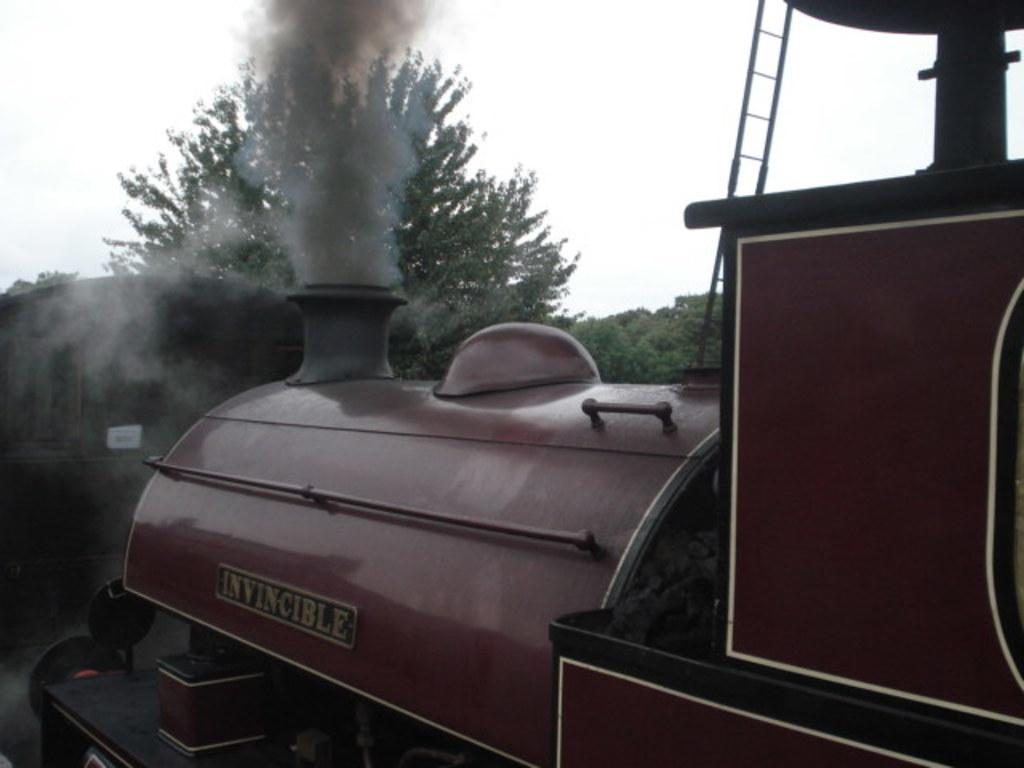What type of vehicle is in the image? There is a steam engine in the image. What object can be seen near the steam engine? There is a ladder in the image. What type of natural vegetation is visible in the image? There are trees in the image. What is visible above the steam engine and trees? The sky is visible in the image. What type of hammer is being used to create the effect seen in the image? There is no hammer or any effect being created in the image; it features a steam engine, a ladder, trees, and the sky. 